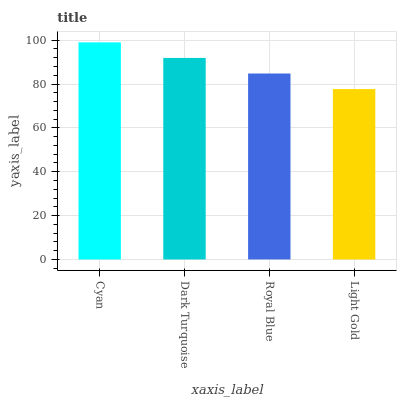Is Dark Turquoise the minimum?
Answer yes or no. No. Is Dark Turquoise the maximum?
Answer yes or no. No. Is Cyan greater than Dark Turquoise?
Answer yes or no. Yes. Is Dark Turquoise less than Cyan?
Answer yes or no. Yes. Is Dark Turquoise greater than Cyan?
Answer yes or no. No. Is Cyan less than Dark Turquoise?
Answer yes or no. No. Is Dark Turquoise the high median?
Answer yes or no. Yes. Is Royal Blue the low median?
Answer yes or no. Yes. Is Cyan the high median?
Answer yes or no. No. Is Light Gold the low median?
Answer yes or no. No. 